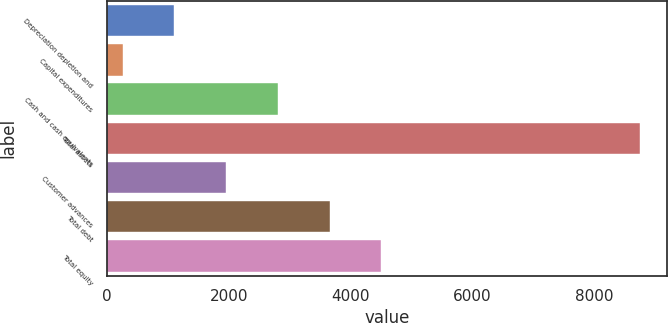Convert chart. <chart><loc_0><loc_0><loc_500><loc_500><bar_chart><fcel>Depreciation depletion and<fcel>Capital expenditures<fcel>Cash and cash equivalents<fcel>Total assets<fcel>Customer advances<fcel>Total debt<fcel>Total equity<nl><fcel>1108.14<fcel>258.1<fcel>2808.22<fcel>8758.5<fcel>1958.18<fcel>3658.26<fcel>4508.3<nl></chart> 